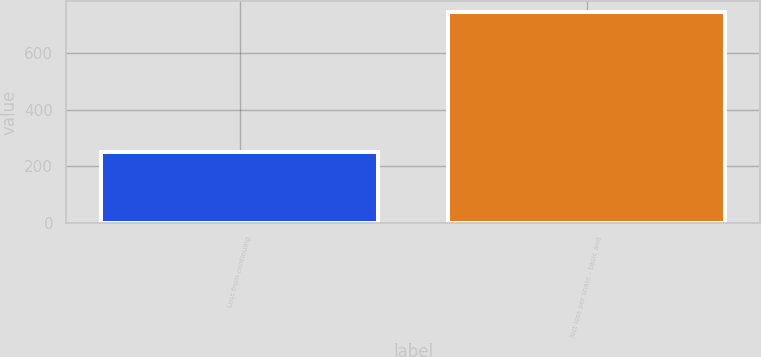<chart> <loc_0><loc_0><loc_500><loc_500><bar_chart><fcel>Loss from continuing<fcel>Net loss per share - basic and<nl><fcel>248.62<fcel>745.82<nl></chart> 